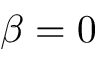Convert formula to latex. <formula><loc_0><loc_0><loc_500><loc_500>\beta = 0</formula> 